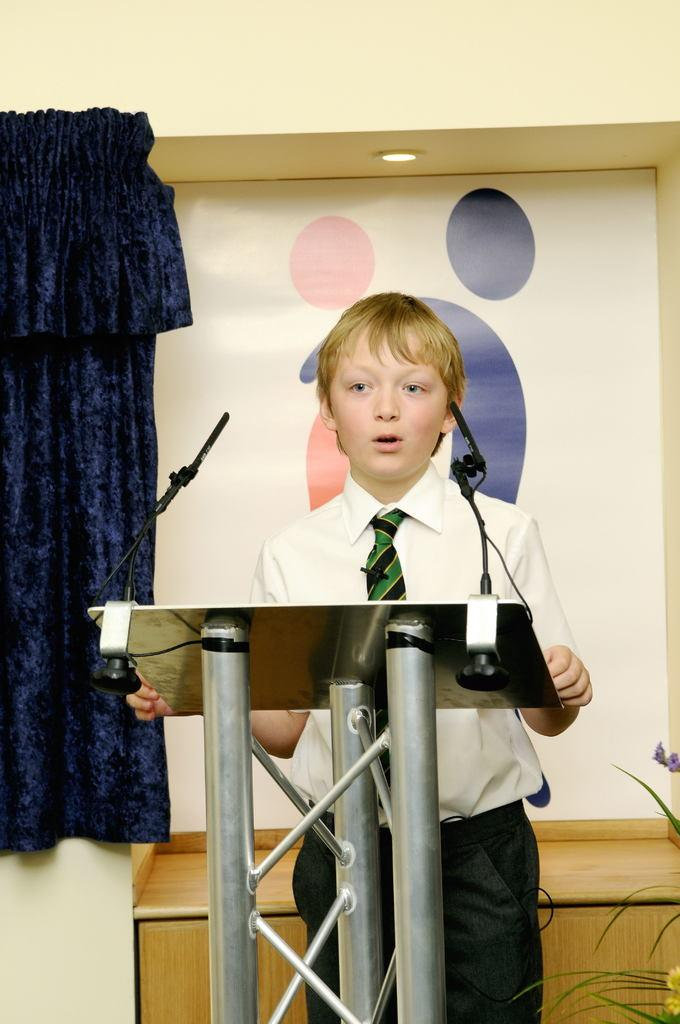Who is the main subject in the image? There is a boy in the image. What is the boy wearing? The boy is wearing a student uniform. What is the boy doing in the image? The boy is standing at a speech desk and giving a speech. What can be seen in the background of the image? There is a white color board and a blue curtain in the background. What type of bone is visible on the color board in the image? There is no bone present on the color board in the image. Is the boy's grandmother in the image? There is no indication of the boy's grandmother in the image. 